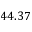Convert formula to latex. <formula><loc_0><loc_0><loc_500><loc_500>4 4 . 3 7</formula> 